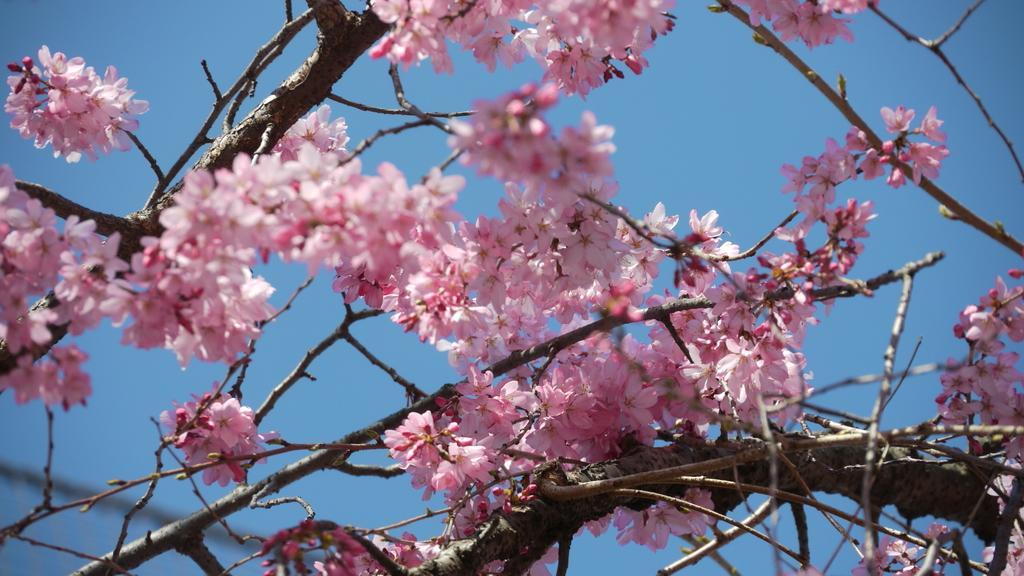Can you describe this image briefly? In this image there is a tree and we can see flowers. In the background there is sky. 